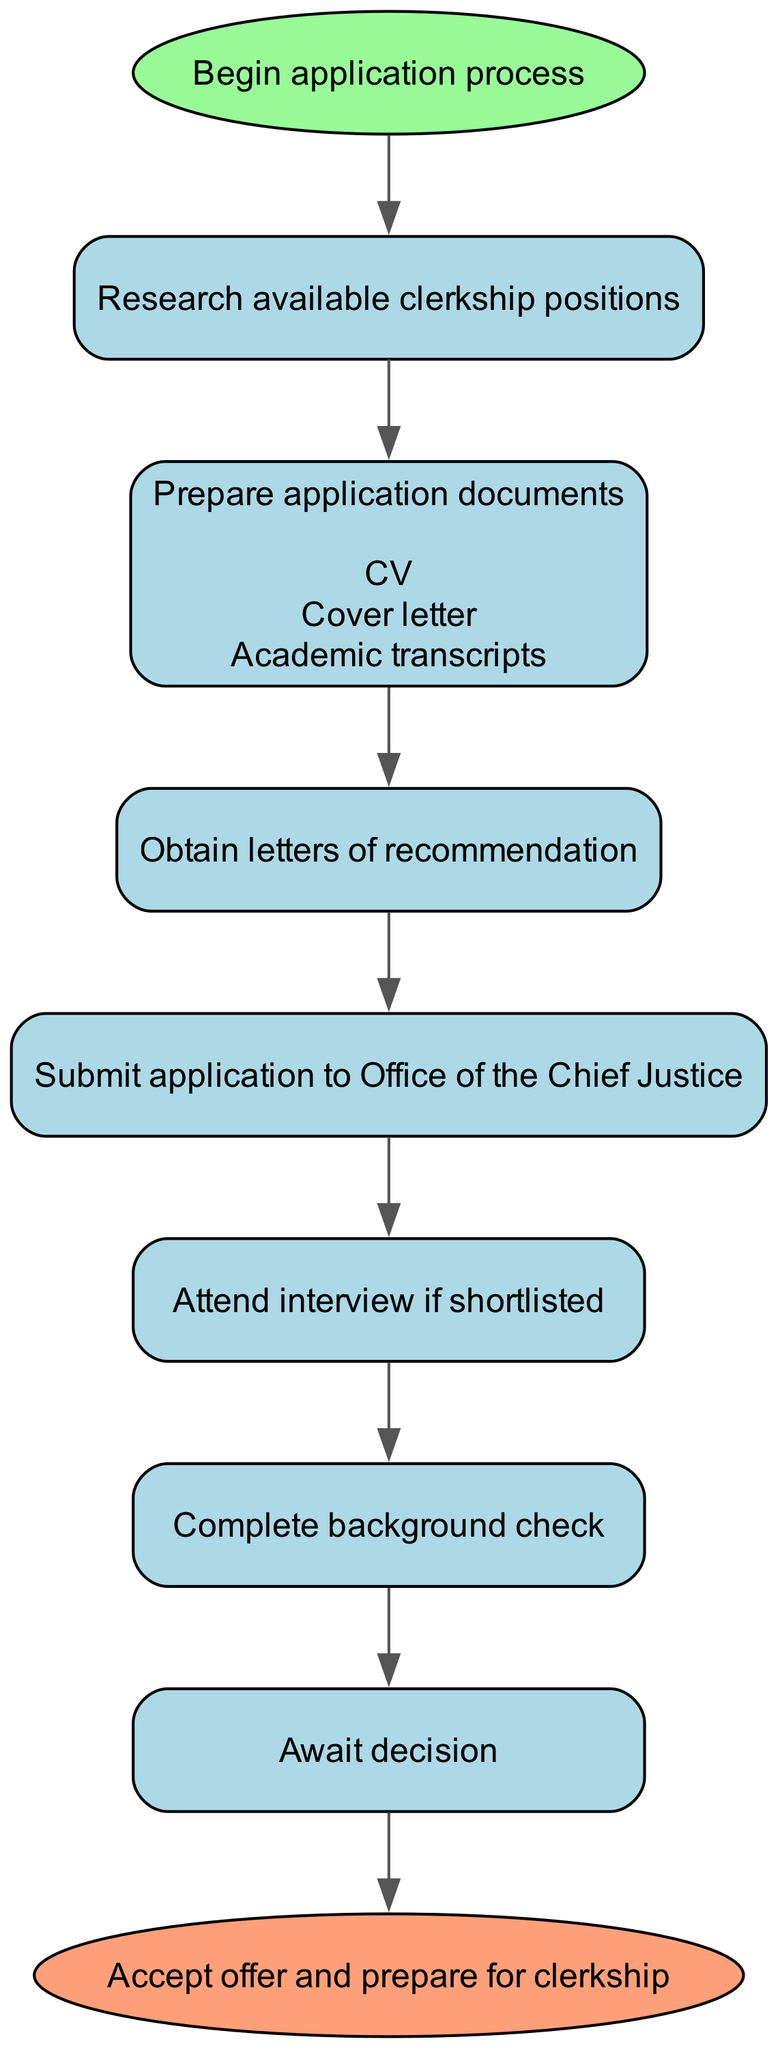What is the first step in the application process? The first step shown in the diagram is labeled "Begin application process." This indicates that the application journey starts with this action.
Answer: Begin application process How many documents need to be prepared before submitting the application? In the "Prepare application documents" node, three sub-elements are listed: CV, Cover letter, and Academic transcripts. Therefore, a total of three documents need to be prepared.
Answer: Three What do you need to do after submitting your application? Following the "Submit application to Office of the Chief Justice" node, the direct next step is "Attend interview if shortlisted." This outlines the action required after submission.
Answer: Attend interview if shortlisted Which step comes directly after obtaining letters of recommendation? The step following "Obtain letters of recommendation" is "Submit application to Office of the Chief Justice." This shows the flow of actions in the application process following the recommendation letters.
Answer: Submit application to Office of the Chief Justice Is there a step that involves a background check? Yes, there is a step labeled "Complete background check" which is part of the process. This indicates an essential verification step occurs after an interview.
Answer: Complete background check What is the final decision you need to await after completing the background check? The diagram indicates that after "Complete background check," the next step is to "Await decision." This is the last action that requires patience before moving on.
Answer: Await decision How many total steps are shown in the diagram? The diagram illustrates a total of eight distinct steps from start to finish, encompassing all phases of applying for the clerkship.
Answer: Eight What action must be taken if shortlisted after the interview? If you are shortlisted after the interview stage, you need to "Complete background check." This step is crucial in the final selection process.
Answer: Complete background check What is the action taken if the decision is favorable? If the decision is favorable, the subsequent action is to "Accept offer and prepare for clerkship." This signifies the transition to the clerkship itself.
Answer: Accept offer and prepare for clerkship 